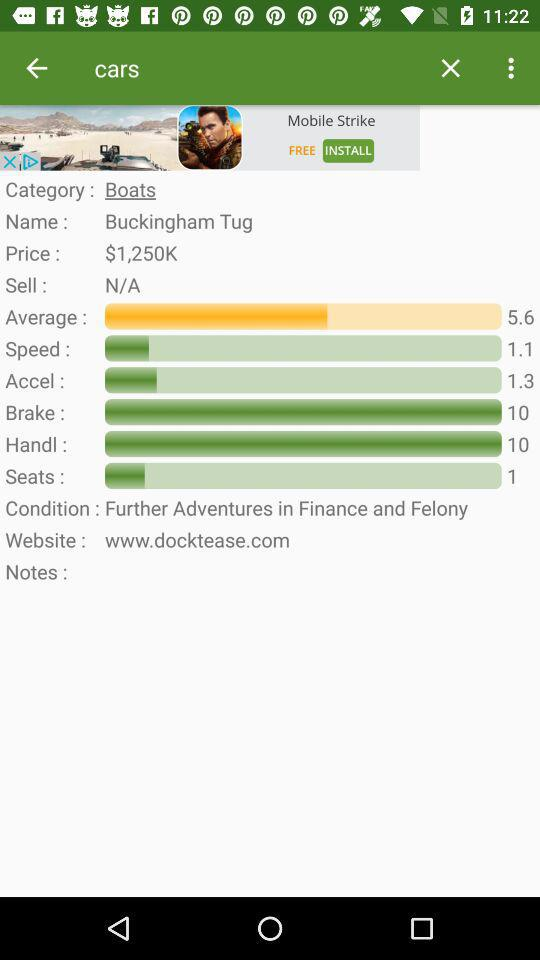What is the website given on the screen? The website given on the screen is www.docktease.com. 